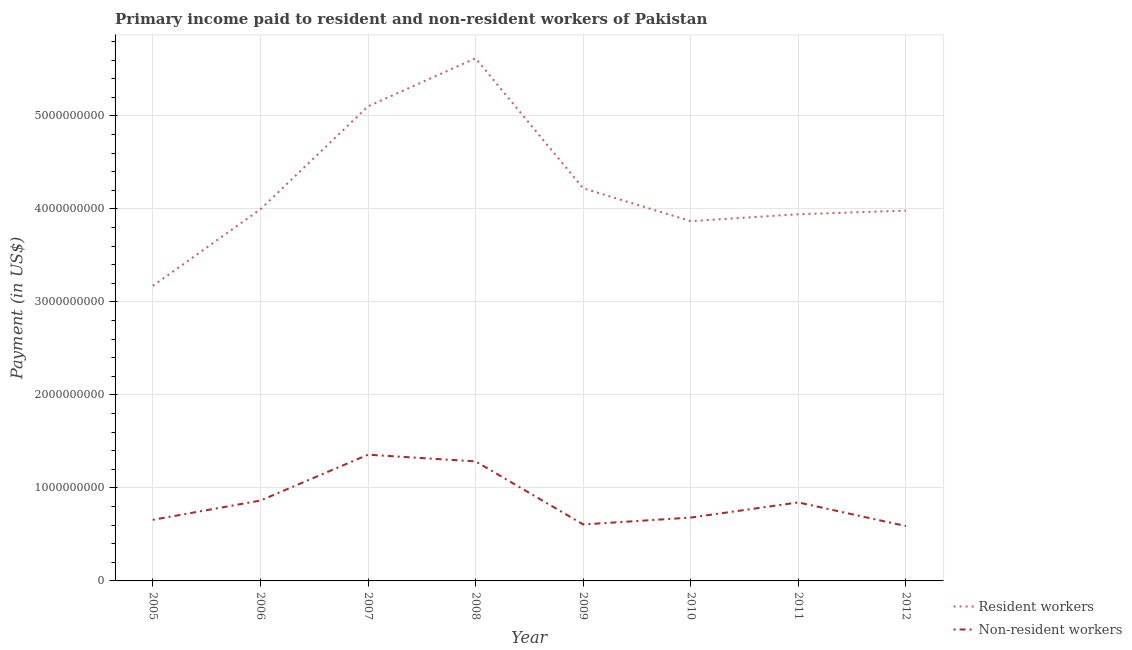Does the line corresponding to payment made to resident workers intersect with the line corresponding to payment made to non-resident workers?
Keep it short and to the point. No. Is the number of lines equal to the number of legend labels?
Offer a terse response. Yes. What is the payment made to resident workers in 2010?
Your answer should be very brief. 3.87e+09. Across all years, what is the maximum payment made to non-resident workers?
Keep it short and to the point. 1.36e+09. Across all years, what is the minimum payment made to resident workers?
Your answer should be compact. 3.17e+09. In which year was the payment made to resident workers maximum?
Keep it short and to the point. 2008. In which year was the payment made to non-resident workers minimum?
Ensure brevity in your answer.  2012. What is the total payment made to non-resident workers in the graph?
Your response must be concise. 6.88e+09. What is the difference between the payment made to non-resident workers in 2007 and that in 2012?
Give a very brief answer. 7.68e+08. What is the difference between the payment made to non-resident workers in 2006 and the payment made to resident workers in 2005?
Your answer should be compact. -2.31e+09. What is the average payment made to non-resident workers per year?
Provide a succinct answer. 8.61e+08. In the year 2008, what is the difference between the payment made to non-resident workers and payment made to resident workers?
Your answer should be compact. -4.33e+09. What is the ratio of the payment made to non-resident workers in 2009 to that in 2011?
Your response must be concise. 0.72. Is the payment made to non-resident workers in 2005 less than that in 2006?
Give a very brief answer. Yes. Is the difference between the payment made to non-resident workers in 2007 and 2012 greater than the difference between the payment made to resident workers in 2007 and 2012?
Keep it short and to the point. No. What is the difference between the highest and the second highest payment made to resident workers?
Give a very brief answer. 5.17e+08. What is the difference between the highest and the lowest payment made to non-resident workers?
Give a very brief answer. 7.68e+08. In how many years, is the payment made to resident workers greater than the average payment made to resident workers taken over all years?
Make the answer very short. 2. How many years are there in the graph?
Your answer should be very brief. 8. What is the difference between two consecutive major ticks on the Y-axis?
Make the answer very short. 1.00e+09. Does the graph contain any zero values?
Ensure brevity in your answer.  No. How many legend labels are there?
Your answer should be very brief. 2. What is the title of the graph?
Make the answer very short. Primary income paid to resident and non-resident workers of Pakistan. Does "All education staff compensation" appear as one of the legend labels in the graph?
Your answer should be very brief. No. What is the label or title of the Y-axis?
Give a very brief answer. Payment (in US$). What is the Payment (in US$) in Resident workers in 2005?
Ensure brevity in your answer.  3.17e+09. What is the Payment (in US$) in Non-resident workers in 2005?
Provide a succinct answer. 6.57e+08. What is the Payment (in US$) in Resident workers in 2006?
Offer a terse response. 4.00e+09. What is the Payment (in US$) in Non-resident workers in 2006?
Provide a short and direct response. 8.64e+08. What is the Payment (in US$) of Resident workers in 2007?
Your answer should be compact. 5.10e+09. What is the Payment (in US$) of Non-resident workers in 2007?
Make the answer very short. 1.36e+09. What is the Payment (in US$) in Resident workers in 2008?
Keep it short and to the point. 5.62e+09. What is the Payment (in US$) in Non-resident workers in 2008?
Give a very brief answer. 1.28e+09. What is the Payment (in US$) of Resident workers in 2009?
Make the answer very short. 4.22e+09. What is the Payment (in US$) in Non-resident workers in 2009?
Ensure brevity in your answer.  6.07e+08. What is the Payment (in US$) of Resident workers in 2010?
Provide a short and direct response. 3.87e+09. What is the Payment (in US$) of Non-resident workers in 2010?
Ensure brevity in your answer.  6.81e+08. What is the Payment (in US$) of Resident workers in 2011?
Ensure brevity in your answer.  3.94e+09. What is the Payment (in US$) of Non-resident workers in 2011?
Offer a terse response. 8.44e+08. What is the Payment (in US$) of Resident workers in 2012?
Ensure brevity in your answer.  3.98e+09. What is the Payment (in US$) in Non-resident workers in 2012?
Make the answer very short. 5.89e+08. Across all years, what is the maximum Payment (in US$) of Resident workers?
Your response must be concise. 5.62e+09. Across all years, what is the maximum Payment (in US$) in Non-resident workers?
Your answer should be compact. 1.36e+09. Across all years, what is the minimum Payment (in US$) in Resident workers?
Your answer should be compact. 3.17e+09. Across all years, what is the minimum Payment (in US$) of Non-resident workers?
Keep it short and to the point. 5.89e+08. What is the total Payment (in US$) of Resident workers in the graph?
Keep it short and to the point. 3.39e+1. What is the total Payment (in US$) in Non-resident workers in the graph?
Your answer should be compact. 6.88e+09. What is the difference between the Payment (in US$) in Resident workers in 2005 and that in 2006?
Make the answer very short. -8.23e+08. What is the difference between the Payment (in US$) of Non-resident workers in 2005 and that in 2006?
Offer a terse response. -2.07e+08. What is the difference between the Payment (in US$) of Resident workers in 2005 and that in 2007?
Give a very brief answer. -1.93e+09. What is the difference between the Payment (in US$) in Non-resident workers in 2005 and that in 2007?
Offer a terse response. -7.00e+08. What is the difference between the Payment (in US$) of Resident workers in 2005 and that in 2008?
Provide a short and direct response. -2.45e+09. What is the difference between the Payment (in US$) of Non-resident workers in 2005 and that in 2008?
Provide a succinct answer. -6.28e+08. What is the difference between the Payment (in US$) of Resident workers in 2005 and that in 2009?
Offer a terse response. -1.05e+09. What is the difference between the Payment (in US$) of Non-resident workers in 2005 and that in 2009?
Give a very brief answer. 5.00e+07. What is the difference between the Payment (in US$) in Resident workers in 2005 and that in 2010?
Give a very brief answer. -6.96e+08. What is the difference between the Payment (in US$) of Non-resident workers in 2005 and that in 2010?
Your answer should be very brief. -2.40e+07. What is the difference between the Payment (in US$) in Resident workers in 2005 and that in 2011?
Your response must be concise. -7.70e+08. What is the difference between the Payment (in US$) of Non-resident workers in 2005 and that in 2011?
Your answer should be compact. -1.87e+08. What is the difference between the Payment (in US$) of Resident workers in 2005 and that in 2012?
Ensure brevity in your answer.  -8.09e+08. What is the difference between the Payment (in US$) in Non-resident workers in 2005 and that in 2012?
Provide a short and direct response. 6.75e+07. What is the difference between the Payment (in US$) in Resident workers in 2006 and that in 2007?
Make the answer very short. -1.11e+09. What is the difference between the Payment (in US$) in Non-resident workers in 2006 and that in 2007?
Your answer should be compact. -4.93e+08. What is the difference between the Payment (in US$) in Resident workers in 2006 and that in 2008?
Provide a short and direct response. -1.62e+09. What is the difference between the Payment (in US$) of Non-resident workers in 2006 and that in 2008?
Your response must be concise. -4.21e+08. What is the difference between the Payment (in US$) of Resident workers in 2006 and that in 2009?
Make the answer very short. -2.26e+08. What is the difference between the Payment (in US$) in Non-resident workers in 2006 and that in 2009?
Ensure brevity in your answer.  2.57e+08. What is the difference between the Payment (in US$) in Resident workers in 2006 and that in 2010?
Your answer should be very brief. 1.27e+08. What is the difference between the Payment (in US$) of Non-resident workers in 2006 and that in 2010?
Your response must be concise. 1.83e+08. What is the difference between the Payment (in US$) of Resident workers in 2006 and that in 2011?
Offer a terse response. 5.34e+07. What is the difference between the Payment (in US$) of Non-resident workers in 2006 and that in 2011?
Keep it short and to the point. 2.01e+07. What is the difference between the Payment (in US$) in Resident workers in 2006 and that in 2012?
Offer a terse response. 1.46e+07. What is the difference between the Payment (in US$) of Non-resident workers in 2006 and that in 2012?
Give a very brief answer. 2.75e+08. What is the difference between the Payment (in US$) of Resident workers in 2007 and that in 2008?
Your answer should be compact. -5.17e+08. What is the difference between the Payment (in US$) in Non-resident workers in 2007 and that in 2008?
Your answer should be very brief. 7.20e+07. What is the difference between the Payment (in US$) in Resident workers in 2007 and that in 2009?
Make the answer very short. 8.81e+08. What is the difference between the Payment (in US$) in Non-resident workers in 2007 and that in 2009?
Ensure brevity in your answer.  7.50e+08. What is the difference between the Payment (in US$) of Resident workers in 2007 and that in 2010?
Provide a short and direct response. 1.23e+09. What is the difference between the Payment (in US$) of Non-resident workers in 2007 and that in 2010?
Offer a very short reply. 6.76e+08. What is the difference between the Payment (in US$) of Resident workers in 2007 and that in 2011?
Provide a short and direct response. 1.16e+09. What is the difference between the Payment (in US$) of Non-resident workers in 2007 and that in 2011?
Offer a terse response. 5.13e+08. What is the difference between the Payment (in US$) in Resident workers in 2007 and that in 2012?
Your answer should be very brief. 1.12e+09. What is the difference between the Payment (in US$) of Non-resident workers in 2007 and that in 2012?
Your answer should be very brief. 7.68e+08. What is the difference between the Payment (in US$) in Resident workers in 2008 and that in 2009?
Make the answer very short. 1.40e+09. What is the difference between the Payment (in US$) in Non-resident workers in 2008 and that in 2009?
Make the answer very short. 6.78e+08. What is the difference between the Payment (in US$) of Resident workers in 2008 and that in 2010?
Make the answer very short. 1.75e+09. What is the difference between the Payment (in US$) in Non-resident workers in 2008 and that in 2010?
Ensure brevity in your answer.  6.04e+08. What is the difference between the Payment (in US$) in Resident workers in 2008 and that in 2011?
Offer a very short reply. 1.68e+09. What is the difference between the Payment (in US$) in Non-resident workers in 2008 and that in 2011?
Offer a terse response. 4.41e+08. What is the difference between the Payment (in US$) of Resident workers in 2008 and that in 2012?
Give a very brief answer. 1.64e+09. What is the difference between the Payment (in US$) of Non-resident workers in 2008 and that in 2012?
Offer a very short reply. 6.96e+08. What is the difference between the Payment (in US$) in Resident workers in 2009 and that in 2010?
Offer a terse response. 3.53e+08. What is the difference between the Payment (in US$) of Non-resident workers in 2009 and that in 2010?
Your answer should be compact. -7.40e+07. What is the difference between the Payment (in US$) in Resident workers in 2009 and that in 2011?
Your answer should be compact. 2.79e+08. What is the difference between the Payment (in US$) in Non-resident workers in 2009 and that in 2011?
Your answer should be compact. -2.37e+08. What is the difference between the Payment (in US$) in Resident workers in 2009 and that in 2012?
Provide a short and direct response. 2.40e+08. What is the difference between the Payment (in US$) of Non-resident workers in 2009 and that in 2012?
Give a very brief answer. 1.75e+07. What is the difference between the Payment (in US$) of Resident workers in 2010 and that in 2011?
Ensure brevity in your answer.  -7.41e+07. What is the difference between the Payment (in US$) of Non-resident workers in 2010 and that in 2011?
Offer a terse response. -1.63e+08. What is the difference between the Payment (in US$) in Resident workers in 2010 and that in 2012?
Provide a short and direct response. -1.13e+08. What is the difference between the Payment (in US$) of Non-resident workers in 2010 and that in 2012?
Your answer should be compact. 9.15e+07. What is the difference between the Payment (in US$) of Resident workers in 2011 and that in 2012?
Offer a terse response. -3.88e+07. What is the difference between the Payment (in US$) in Non-resident workers in 2011 and that in 2012?
Provide a short and direct response. 2.54e+08. What is the difference between the Payment (in US$) in Resident workers in 2005 and the Payment (in US$) in Non-resident workers in 2006?
Make the answer very short. 2.31e+09. What is the difference between the Payment (in US$) in Resident workers in 2005 and the Payment (in US$) in Non-resident workers in 2007?
Offer a very short reply. 1.82e+09. What is the difference between the Payment (in US$) in Resident workers in 2005 and the Payment (in US$) in Non-resident workers in 2008?
Your answer should be very brief. 1.89e+09. What is the difference between the Payment (in US$) of Resident workers in 2005 and the Payment (in US$) of Non-resident workers in 2009?
Offer a very short reply. 2.56e+09. What is the difference between the Payment (in US$) of Resident workers in 2005 and the Payment (in US$) of Non-resident workers in 2010?
Offer a very short reply. 2.49e+09. What is the difference between the Payment (in US$) of Resident workers in 2005 and the Payment (in US$) of Non-resident workers in 2011?
Keep it short and to the point. 2.33e+09. What is the difference between the Payment (in US$) of Resident workers in 2005 and the Payment (in US$) of Non-resident workers in 2012?
Your answer should be compact. 2.58e+09. What is the difference between the Payment (in US$) of Resident workers in 2006 and the Payment (in US$) of Non-resident workers in 2007?
Your answer should be compact. 2.64e+09. What is the difference between the Payment (in US$) of Resident workers in 2006 and the Payment (in US$) of Non-resident workers in 2008?
Make the answer very short. 2.71e+09. What is the difference between the Payment (in US$) in Resident workers in 2006 and the Payment (in US$) in Non-resident workers in 2009?
Make the answer very short. 3.39e+09. What is the difference between the Payment (in US$) of Resident workers in 2006 and the Payment (in US$) of Non-resident workers in 2010?
Make the answer very short. 3.31e+09. What is the difference between the Payment (in US$) in Resident workers in 2006 and the Payment (in US$) in Non-resident workers in 2011?
Provide a short and direct response. 3.15e+09. What is the difference between the Payment (in US$) in Resident workers in 2006 and the Payment (in US$) in Non-resident workers in 2012?
Your answer should be compact. 3.41e+09. What is the difference between the Payment (in US$) in Resident workers in 2007 and the Payment (in US$) in Non-resident workers in 2008?
Provide a short and direct response. 3.82e+09. What is the difference between the Payment (in US$) of Resident workers in 2007 and the Payment (in US$) of Non-resident workers in 2009?
Provide a succinct answer. 4.50e+09. What is the difference between the Payment (in US$) of Resident workers in 2007 and the Payment (in US$) of Non-resident workers in 2010?
Give a very brief answer. 4.42e+09. What is the difference between the Payment (in US$) of Resident workers in 2007 and the Payment (in US$) of Non-resident workers in 2011?
Provide a short and direct response. 4.26e+09. What is the difference between the Payment (in US$) of Resident workers in 2007 and the Payment (in US$) of Non-resident workers in 2012?
Offer a very short reply. 4.51e+09. What is the difference between the Payment (in US$) of Resident workers in 2008 and the Payment (in US$) of Non-resident workers in 2009?
Your response must be concise. 5.01e+09. What is the difference between the Payment (in US$) in Resident workers in 2008 and the Payment (in US$) in Non-resident workers in 2010?
Your response must be concise. 4.94e+09. What is the difference between the Payment (in US$) of Resident workers in 2008 and the Payment (in US$) of Non-resident workers in 2011?
Your response must be concise. 4.78e+09. What is the difference between the Payment (in US$) in Resident workers in 2008 and the Payment (in US$) in Non-resident workers in 2012?
Ensure brevity in your answer.  5.03e+09. What is the difference between the Payment (in US$) of Resident workers in 2009 and the Payment (in US$) of Non-resident workers in 2010?
Your answer should be very brief. 3.54e+09. What is the difference between the Payment (in US$) of Resident workers in 2009 and the Payment (in US$) of Non-resident workers in 2011?
Keep it short and to the point. 3.38e+09. What is the difference between the Payment (in US$) in Resident workers in 2009 and the Payment (in US$) in Non-resident workers in 2012?
Your answer should be compact. 3.63e+09. What is the difference between the Payment (in US$) in Resident workers in 2010 and the Payment (in US$) in Non-resident workers in 2011?
Offer a very short reply. 3.02e+09. What is the difference between the Payment (in US$) of Resident workers in 2010 and the Payment (in US$) of Non-resident workers in 2012?
Provide a short and direct response. 3.28e+09. What is the difference between the Payment (in US$) in Resident workers in 2011 and the Payment (in US$) in Non-resident workers in 2012?
Your response must be concise. 3.35e+09. What is the average Payment (in US$) in Resident workers per year?
Provide a short and direct response. 4.24e+09. What is the average Payment (in US$) in Non-resident workers per year?
Your answer should be very brief. 8.61e+08. In the year 2005, what is the difference between the Payment (in US$) of Resident workers and Payment (in US$) of Non-resident workers?
Ensure brevity in your answer.  2.52e+09. In the year 2006, what is the difference between the Payment (in US$) of Resident workers and Payment (in US$) of Non-resident workers?
Make the answer very short. 3.13e+09. In the year 2007, what is the difference between the Payment (in US$) of Resident workers and Payment (in US$) of Non-resident workers?
Offer a terse response. 3.74e+09. In the year 2008, what is the difference between the Payment (in US$) of Resident workers and Payment (in US$) of Non-resident workers?
Provide a succinct answer. 4.33e+09. In the year 2009, what is the difference between the Payment (in US$) of Resident workers and Payment (in US$) of Non-resident workers?
Your response must be concise. 3.61e+09. In the year 2010, what is the difference between the Payment (in US$) in Resident workers and Payment (in US$) in Non-resident workers?
Keep it short and to the point. 3.19e+09. In the year 2011, what is the difference between the Payment (in US$) of Resident workers and Payment (in US$) of Non-resident workers?
Your response must be concise. 3.10e+09. In the year 2012, what is the difference between the Payment (in US$) of Resident workers and Payment (in US$) of Non-resident workers?
Ensure brevity in your answer.  3.39e+09. What is the ratio of the Payment (in US$) of Resident workers in 2005 to that in 2006?
Your answer should be compact. 0.79. What is the ratio of the Payment (in US$) of Non-resident workers in 2005 to that in 2006?
Ensure brevity in your answer.  0.76. What is the ratio of the Payment (in US$) of Resident workers in 2005 to that in 2007?
Your answer should be very brief. 0.62. What is the ratio of the Payment (in US$) of Non-resident workers in 2005 to that in 2007?
Offer a very short reply. 0.48. What is the ratio of the Payment (in US$) of Resident workers in 2005 to that in 2008?
Make the answer very short. 0.56. What is the ratio of the Payment (in US$) of Non-resident workers in 2005 to that in 2008?
Ensure brevity in your answer.  0.51. What is the ratio of the Payment (in US$) in Resident workers in 2005 to that in 2009?
Your answer should be very brief. 0.75. What is the ratio of the Payment (in US$) of Non-resident workers in 2005 to that in 2009?
Your answer should be very brief. 1.08. What is the ratio of the Payment (in US$) of Resident workers in 2005 to that in 2010?
Provide a short and direct response. 0.82. What is the ratio of the Payment (in US$) of Non-resident workers in 2005 to that in 2010?
Your response must be concise. 0.96. What is the ratio of the Payment (in US$) of Resident workers in 2005 to that in 2011?
Give a very brief answer. 0.8. What is the ratio of the Payment (in US$) in Non-resident workers in 2005 to that in 2011?
Offer a very short reply. 0.78. What is the ratio of the Payment (in US$) of Resident workers in 2005 to that in 2012?
Ensure brevity in your answer.  0.8. What is the ratio of the Payment (in US$) of Non-resident workers in 2005 to that in 2012?
Provide a short and direct response. 1.11. What is the ratio of the Payment (in US$) in Resident workers in 2006 to that in 2007?
Ensure brevity in your answer.  0.78. What is the ratio of the Payment (in US$) in Non-resident workers in 2006 to that in 2007?
Make the answer very short. 0.64. What is the ratio of the Payment (in US$) of Resident workers in 2006 to that in 2008?
Your answer should be compact. 0.71. What is the ratio of the Payment (in US$) in Non-resident workers in 2006 to that in 2008?
Your answer should be compact. 0.67. What is the ratio of the Payment (in US$) in Resident workers in 2006 to that in 2009?
Your answer should be compact. 0.95. What is the ratio of the Payment (in US$) of Non-resident workers in 2006 to that in 2009?
Ensure brevity in your answer.  1.42. What is the ratio of the Payment (in US$) of Resident workers in 2006 to that in 2010?
Provide a succinct answer. 1.03. What is the ratio of the Payment (in US$) in Non-resident workers in 2006 to that in 2010?
Keep it short and to the point. 1.27. What is the ratio of the Payment (in US$) of Resident workers in 2006 to that in 2011?
Your answer should be very brief. 1.01. What is the ratio of the Payment (in US$) in Non-resident workers in 2006 to that in 2011?
Give a very brief answer. 1.02. What is the ratio of the Payment (in US$) in Resident workers in 2006 to that in 2012?
Your response must be concise. 1. What is the ratio of the Payment (in US$) of Non-resident workers in 2006 to that in 2012?
Give a very brief answer. 1.47. What is the ratio of the Payment (in US$) in Resident workers in 2007 to that in 2008?
Your answer should be very brief. 0.91. What is the ratio of the Payment (in US$) of Non-resident workers in 2007 to that in 2008?
Offer a very short reply. 1.06. What is the ratio of the Payment (in US$) in Resident workers in 2007 to that in 2009?
Your answer should be very brief. 1.21. What is the ratio of the Payment (in US$) in Non-resident workers in 2007 to that in 2009?
Offer a very short reply. 2.24. What is the ratio of the Payment (in US$) of Resident workers in 2007 to that in 2010?
Your response must be concise. 1.32. What is the ratio of the Payment (in US$) in Non-resident workers in 2007 to that in 2010?
Keep it short and to the point. 1.99. What is the ratio of the Payment (in US$) in Resident workers in 2007 to that in 2011?
Make the answer very short. 1.29. What is the ratio of the Payment (in US$) of Non-resident workers in 2007 to that in 2011?
Make the answer very short. 1.61. What is the ratio of the Payment (in US$) in Resident workers in 2007 to that in 2012?
Offer a terse response. 1.28. What is the ratio of the Payment (in US$) in Non-resident workers in 2007 to that in 2012?
Offer a terse response. 2.3. What is the ratio of the Payment (in US$) of Resident workers in 2008 to that in 2009?
Your answer should be very brief. 1.33. What is the ratio of the Payment (in US$) of Non-resident workers in 2008 to that in 2009?
Provide a succinct answer. 2.12. What is the ratio of the Payment (in US$) in Resident workers in 2008 to that in 2010?
Make the answer very short. 1.45. What is the ratio of the Payment (in US$) of Non-resident workers in 2008 to that in 2010?
Provide a short and direct response. 1.89. What is the ratio of the Payment (in US$) in Resident workers in 2008 to that in 2011?
Provide a short and direct response. 1.43. What is the ratio of the Payment (in US$) in Non-resident workers in 2008 to that in 2011?
Make the answer very short. 1.52. What is the ratio of the Payment (in US$) of Resident workers in 2008 to that in 2012?
Offer a terse response. 1.41. What is the ratio of the Payment (in US$) in Non-resident workers in 2008 to that in 2012?
Provide a short and direct response. 2.18. What is the ratio of the Payment (in US$) in Resident workers in 2009 to that in 2010?
Your answer should be compact. 1.09. What is the ratio of the Payment (in US$) of Non-resident workers in 2009 to that in 2010?
Offer a very short reply. 0.89. What is the ratio of the Payment (in US$) in Resident workers in 2009 to that in 2011?
Your response must be concise. 1.07. What is the ratio of the Payment (in US$) of Non-resident workers in 2009 to that in 2011?
Your answer should be compact. 0.72. What is the ratio of the Payment (in US$) in Resident workers in 2009 to that in 2012?
Make the answer very short. 1.06. What is the ratio of the Payment (in US$) in Non-resident workers in 2009 to that in 2012?
Provide a short and direct response. 1.03. What is the ratio of the Payment (in US$) of Resident workers in 2010 to that in 2011?
Keep it short and to the point. 0.98. What is the ratio of the Payment (in US$) of Non-resident workers in 2010 to that in 2011?
Provide a short and direct response. 0.81. What is the ratio of the Payment (in US$) in Resident workers in 2010 to that in 2012?
Offer a very short reply. 0.97. What is the ratio of the Payment (in US$) in Non-resident workers in 2010 to that in 2012?
Your answer should be very brief. 1.16. What is the ratio of the Payment (in US$) of Resident workers in 2011 to that in 2012?
Your response must be concise. 0.99. What is the ratio of the Payment (in US$) in Non-resident workers in 2011 to that in 2012?
Your answer should be very brief. 1.43. What is the difference between the highest and the second highest Payment (in US$) of Resident workers?
Your answer should be compact. 5.17e+08. What is the difference between the highest and the second highest Payment (in US$) of Non-resident workers?
Provide a succinct answer. 7.20e+07. What is the difference between the highest and the lowest Payment (in US$) of Resident workers?
Keep it short and to the point. 2.45e+09. What is the difference between the highest and the lowest Payment (in US$) in Non-resident workers?
Your answer should be compact. 7.68e+08. 